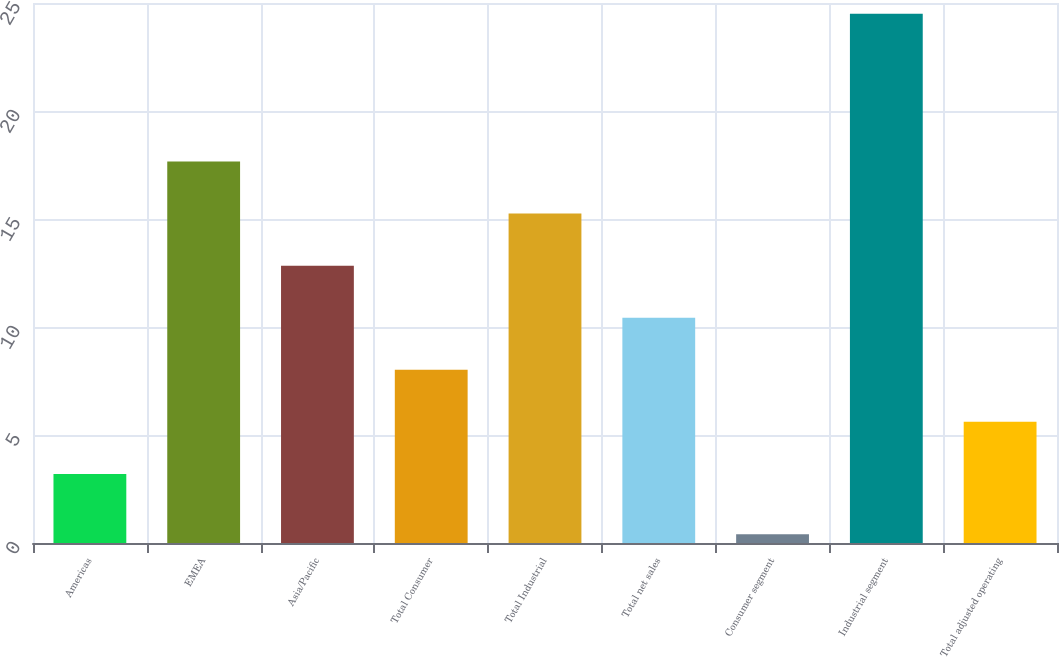Convert chart. <chart><loc_0><loc_0><loc_500><loc_500><bar_chart><fcel>Americas<fcel>EMEA<fcel>Asia/Pacific<fcel>Total Consumer<fcel>Total Industrial<fcel>Total net sales<fcel>Consumer segment<fcel>Industrial segment<fcel>Total adjusted operating<nl><fcel>3.2<fcel>17.66<fcel>12.84<fcel>8.02<fcel>15.25<fcel>10.43<fcel>0.4<fcel>24.5<fcel>5.61<nl></chart> 